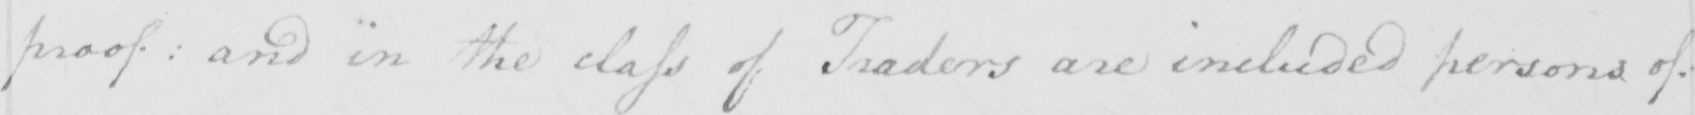What does this handwritten line say? proof :  and in the class of Traders are included persons of 